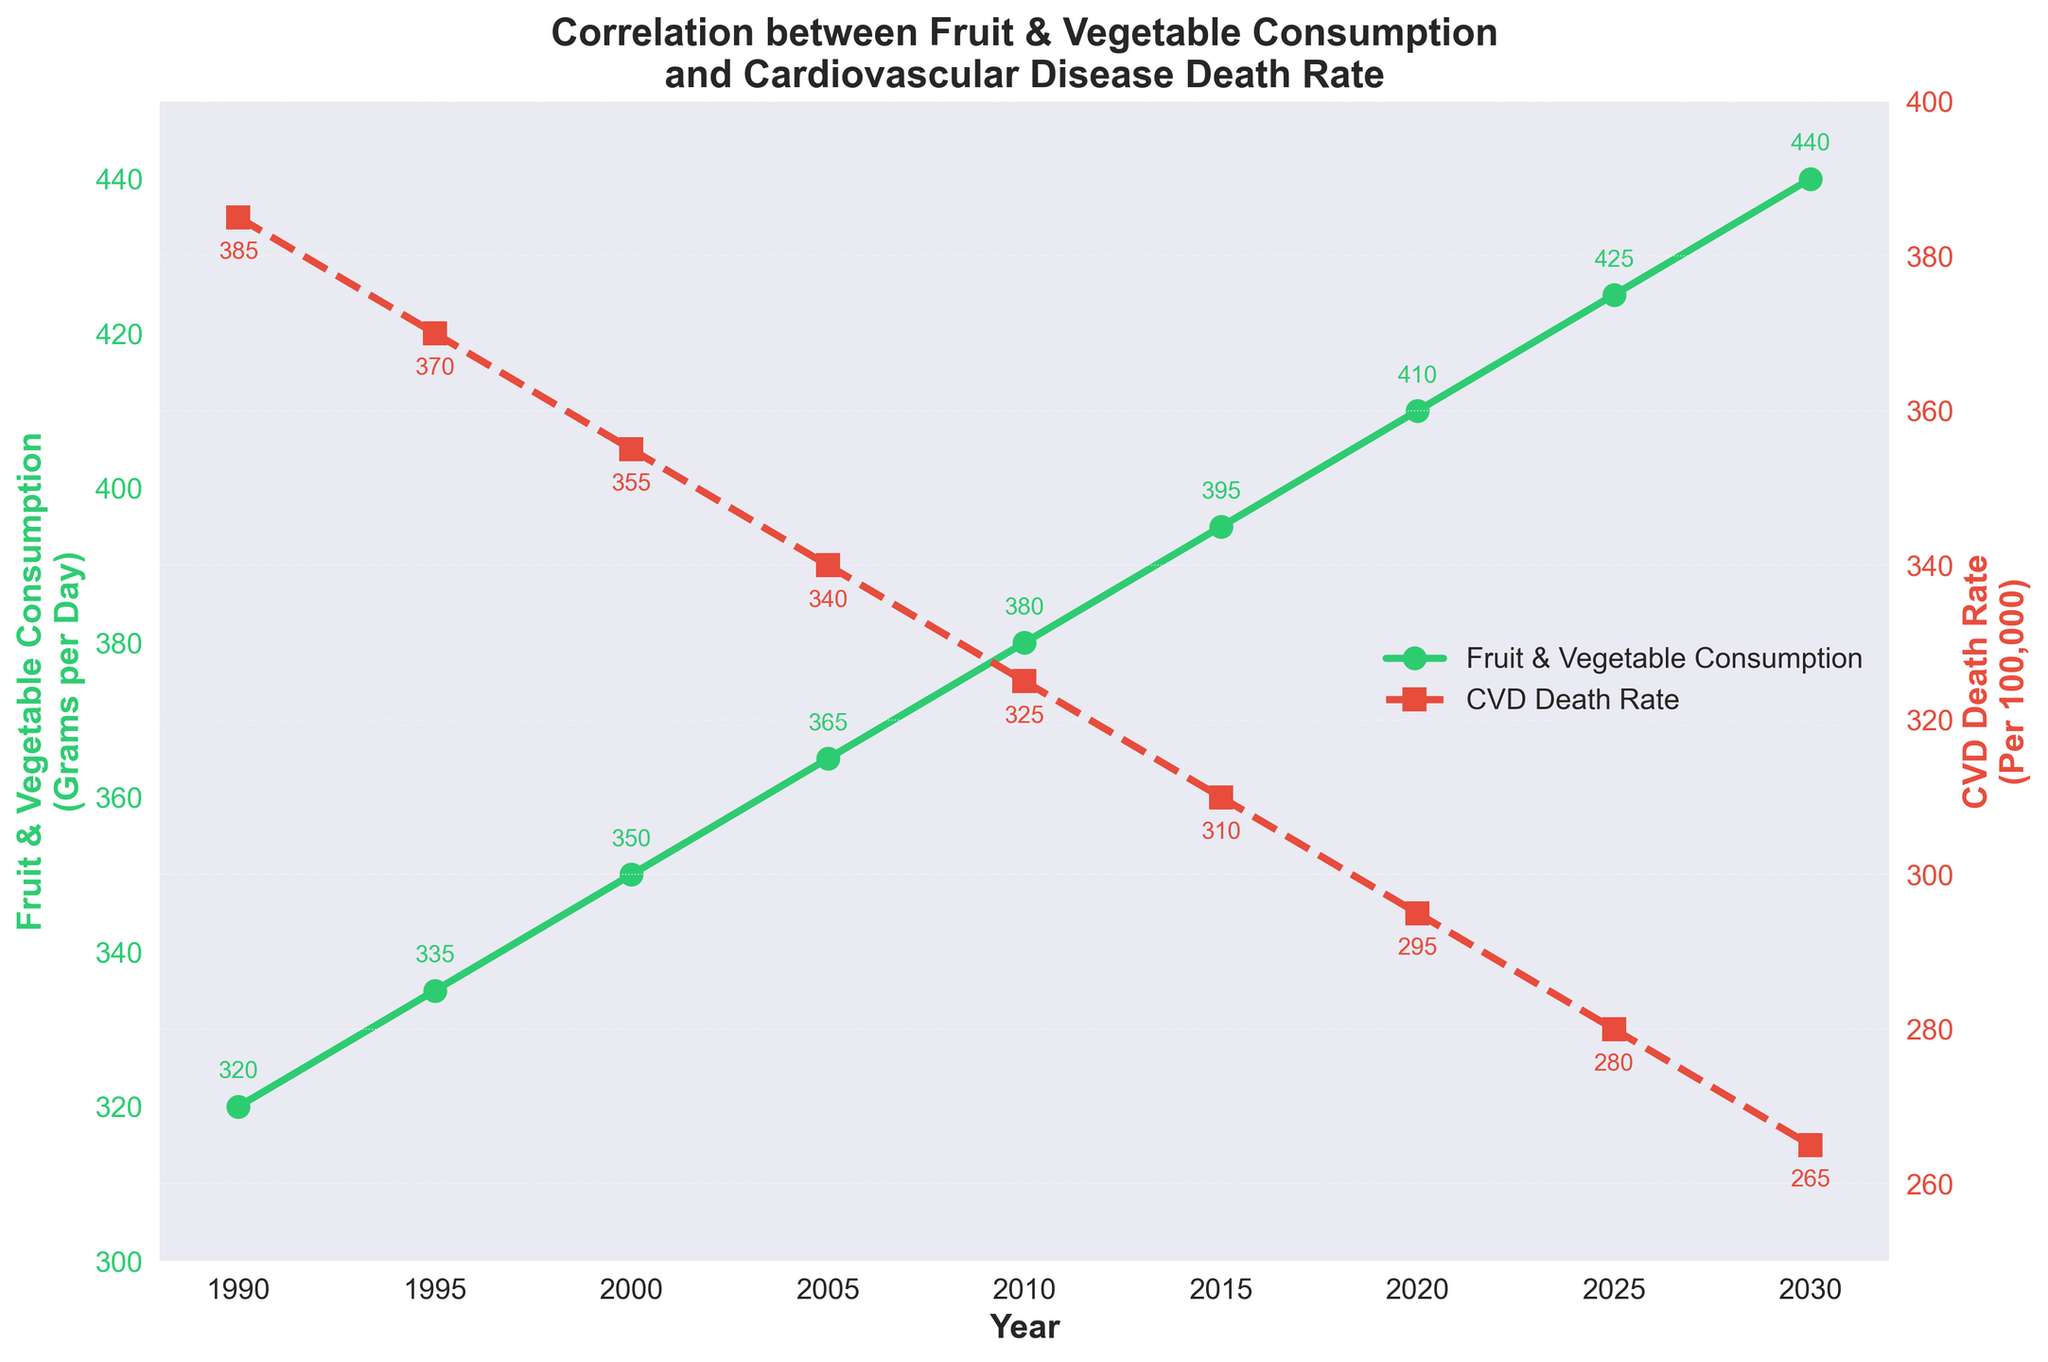Which year exhibited the highest level of fruit and vegetable consumption? According to the green line representing fruit and vegetable consumption, the highest value is reached in 2030 with 440 grams per day.
Answer: 2030 During which period did cardiovascular death rates see the most significant decline? By inspecting the red dashed line representing cardiovascular disease (CVD) death rates, the largest drop is seen between 2015 and 2030, going from 310 to 265 per 100,000.
Answer: 2015-2030 What is the general trend of fruit and vegetable consumption over the years depicted? Observing the green solid line, there is a continuous and steady increase in fruit and vegetable consumption from 1990 to 2030.
Answer: Increasing How much did the fruit and vegetable consumption increase between 1990 and 2020? The consumption in 1990 was 320 grams per day and increased to 410 grams per day by 2020. The difference is 410 - 320 = 90 grams per day.
Answer: 90 grams per day Compare the CVD death rates in 1990 to those in 2020. In 1990, the CVD death rate was 385 per 100,000, and in 2020, it was 295 per 100,000. 385 - 295 = 90 per 100,000 decrease.
Answer: Decreased by 90 per 100,000 Is there any year where the increase in fruit and vegetable consumption appears to correlate directly with a decrease in CVD death rates without interruption? Observing the trends, between each 5-year interval from 1995 to 2030, as the green line increases, the red line decreases almost continuously without interruption.
Answer: Yes, in multiple intervals Which color represents the cardiovascular death rate on the plot? The cardiovascular death rate is depicted by the red dashed line.
Answer: Red What is the visual relationship between fruit and vegetable consumption and CVD death rate? As the green line for fruit and vegetable consumption rises, the red dashed line for CVD death rates falls consistently over time, suggesting a potential inverse correlation.
Answer: Potential inverse correlation 